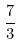Convert formula to latex. <formula><loc_0><loc_0><loc_500><loc_500>\frac { 7 } { 3 }</formula> 